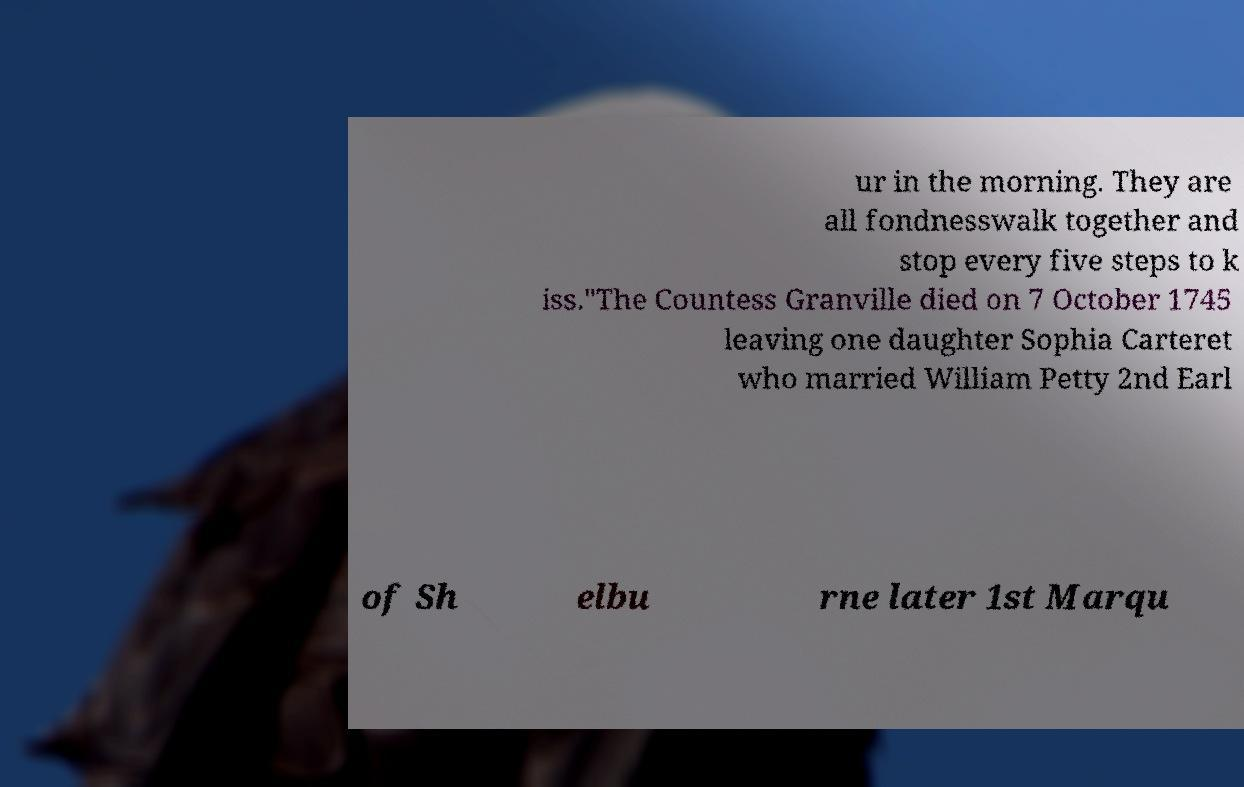I need the written content from this picture converted into text. Can you do that? ur in the morning. They are all fondnesswalk together and stop every five steps to k iss."The Countess Granville died on 7 October 1745 leaving one daughter Sophia Carteret who married William Petty 2nd Earl of Sh elbu rne later 1st Marqu 